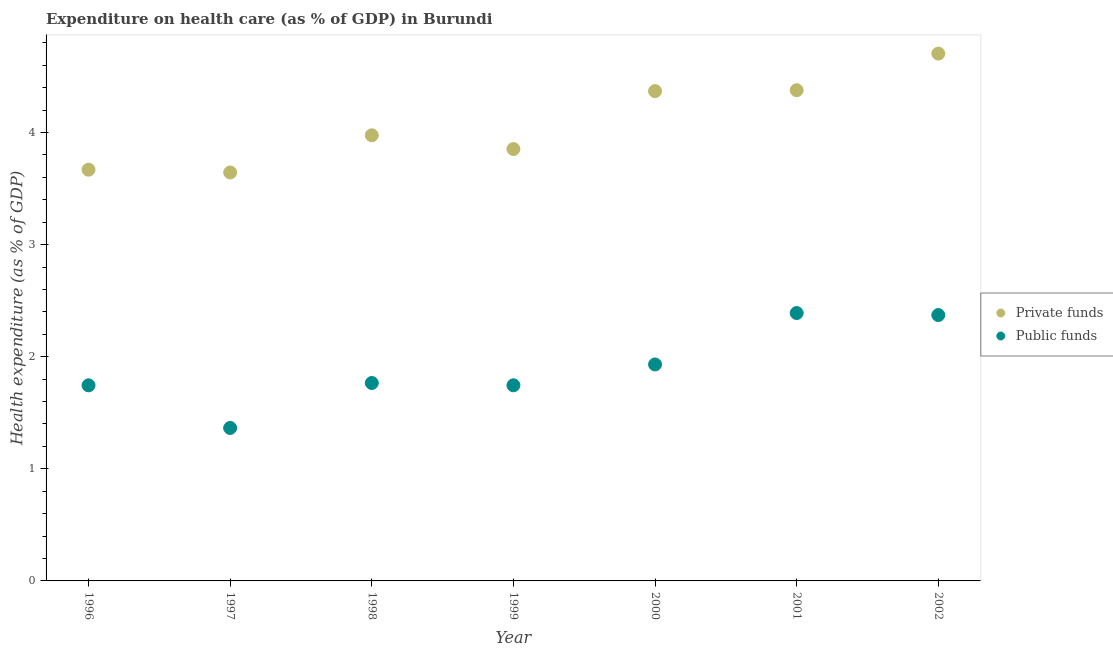What is the amount of private funds spent in healthcare in 2002?
Offer a terse response. 4.7. Across all years, what is the maximum amount of public funds spent in healthcare?
Your answer should be compact. 2.39. Across all years, what is the minimum amount of private funds spent in healthcare?
Your answer should be compact. 3.64. In which year was the amount of public funds spent in healthcare maximum?
Provide a short and direct response. 2001. What is the total amount of public funds spent in healthcare in the graph?
Offer a terse response. 13.31. What is the difference between the amount of private funds spent in healthcare in 2000 and that in 2001?
Keep it short and to the point. -0.01. What is the difference between the amount of public funds spent in healthcare in 2001 and the amount of private funds spent in healthcare in 1996?
Provide a short and direct response. -1.28. What is the average amount of public funds spent in healthcare per year?
Offer a terse response. 1.9. In the year 2002, what is the difference between the amount of public funds spent in healthcare and amount of private funds spent in healthcare?
Ensure brevity in your answer.  -2.33. In how many years, is the amount of private funds spent in healthcare greater than 1.4 %?
Provide a succinct answer. 7. What is the ratio of the amount of public funds spent in healthcare in 1996 to that in 1997?
Offer a terse response. 1.28. Is the amount of private funds spent in healthcare in 1999 less than that in 2000?
Your answer should be compact. Yes. What is the difference between the highest and the second highest amount of private funds spent in healthcare?
Keep it short and to the point. 0.33. What is the difference between the highest and the lowest amount of private funds spent in healthcare?
Provide a short and direct response. 1.06. Is the amount of public funds spent in healthcare strictly greater than the amount of private funds spent in healthcare over the years?
Your answer should be compact. No. Is the amount of public funds spent in healthcare strictly less than the amount of private funds spent in healthcare over the years?
Make the answer very short. Yes. How many years are there in the graph?
Offer a very short reply. 7. Where does the legend appear in the graph?
Your answer should be very brief. Center right. How many legend labels are there?
Give a very brief answer. 2. What is the title of the graph?
Offer a very short reply. Expenditure on health care (as % of GDP) in Burundi. Does "Private funds" appear as one of the legend labels in the graph?
Provide a succinct answer. Yes. What is the label or title of the X-axis?
Provide a succinct answer. Year. What is the label or title of the Y-axis?
Your answer should be compact. Health expenditure (as % of GDP). What is the Health expenditure (as % of GDP) in Private funds in 1996?
Your answer should be compact. 3.67. What is the Health expenditure (as % of GDP) of Public funds in 1996?
Keep it short and to the point. 1.74. What is the Health expenditure (as % of GDP) in Private funds in 1997?
Make the answer very short. 3.64. What is the Health expenditure (as % of GDP) in Public funds in 1997?
Keep it short and to the point. 1.36. What is the Health expenditure (as % of GDP) in Private funds in 1998?
Offer a terse response. 3.97. What is the Health expenditure (as % of GDP) in Public funds in 1998?
Offer a very short reply. 1.77. What is the Health expenditure (as % of GDP) of Private funds in 1999?
Provide a short and direct response. 3.85. What is the Health expenditure (as % of GDP) in Public funds in 1999?
Ensure brevity in your answer.  1.75. What is the Health expenditure (as % of GDP) of Private funds in 2000?
Give a very brief answer. 4.37. What is the Health expenditure (as % of GDP) in Public funds in 2000?
Your answer should be compact. 1.93. What is the Health expenditure (as % of GDP) in Private funds in 2001?
Offer a terse response. 4.38. What is the Health expenditure (as % of GDP) in Public funds in 2001?
Offer a terse response. 2.39. What is the Health expenditure (as % of GDP) in Private funds in 2002?
Provide a short and direct response. 4.7. What is the Health expenditure (as % of GDP) in Public funds in 2002?
Give a very brief answer. 2.37. Across all years, what is the maximum Health expenditure (as % of GDP) in Private funds?
Offer a terse response. 4.7. Across all years, what is the maximum Health expenditure (as % of GDP) of Public funds?
Your response must be concise. 2.39. Across all years, what is the minimum Health expenditure (as % of GDP) of Private funds?
Offer a very short reply. 3.64. Across all years, what is the minimum Health expenditure (as % of GDP) of Public funds?
Your answer should be compact. 1.36. What is the total Health expenditure (as % of GDP) in Private funds in the graph?
Offer a very short reply. 28.59. What is the total Health expenditure (as % of GDP) of Public funds in the graph?
Offer a very short reply. 13.31. What is the difference between the Health expenditure (as % of GDP) in Private funds in 1996 and that in 1997?
Ensure brevity in your answer.  0.02. What is the difference between the Health expenditure (as % of GDP) of Public funds in 1996 and that in 1997?
Offer a very short reply. 0.38. What is the difference between the Health expenditure (as % of GDP) in Private funds in 1996 and that in 1998?
Your answer should be very brief. -0.31. What is the difference between the Health expenditure (as % of GDP) of Public funds in 1996 and that in 1998?
Ensure brevity in your answer.  -0.02. What is the difference between the Health expenditure (as % of GDP) in Private funds in 1996 and that in 1999?
Give a very brief answer. -0.18. What is the difference between the Health expenditure (as % of GDP) of Public funds in 1996 and that in 1999?
Your answer should be compact. -0. What is the difference between the Health expenditure (as % of GDP) of Private funds in 1996 and that in 2000?
Make the answer very short. -0.7. What is the difference between the Health expenditure (as % of GDP) of Public funds in 1996 and that in 2000?
Give a very brief answer. -0.19. What is the difference between the Health expenditure (as % of GDP) in Private funds in 1996 and that in 2001?
Make the answer very short. -0.71. What is the difference between the Health expenditure (as % of GDP) in Public funds in 1996 and that in 2001?
Make the answer very short. -0.64. What is the difference between the Health expenditure (as % of GDP) in Private funds in 1996 and that in 2002?
Your answer should be very brief. -1.04. What is the difference between the Health expenditure (as % of GDP) of Public funds in 1996 and that in 2002?
Make the answer very short. -0.63. What is the difference between the Health expenditure (as % of GDP) of Private funds in 1997 and that in 1998?
Provide a succinct answer. -0.33. What is the difference between the Health expenditure (as % of GDP) of Public funds in 1997 and that in 1998?
Give a very brief answer. -0.4. What is the difference between the Health expenditure (as % of GDP) of Private funds in 1997 and that in 1999?
Your answer should be very brief. -0.21. What is the difference between the Health expenditure (as % of GDP) in Public funds in 1997 and that in 1999?
Ensure brevity in your answer.  -0.38. What is the difference between the Health expenditure (as % of GDP) in Private funds in 1997 and that in 2000?
Offer a terse response. -0.73. What is the difference between the Health expenditure (as % of GDP) in Public funds in 1997 and that in 2000?
Your answer should be compact. -0.57. What is the difference between the Health expenditure (as % of GDP) of Private funds in 1997 and that in 2001?
Your response must be concise. -0.73. What is the difference between the Health expenditure (as % of GDP) in Public funds in 1997 and that in 2001?
Your answer should be compact. -1.02. What is the difference between the Health expenditure (as % of GDP) of Private funds in 1997 and that in 2002?
Make the answer very short. -1.06. What is the difference between the Health expenditure (as % of GDP) of Public funds in 1997 and that in 2002?
Ensure brevity in your answer.  -1.01. What is the difference between the Health expenditure (as % of GDP) in Private funds in 1998 and that in 1999?
Provide a succinct answer. 0.12. What is the difference between the Health expenditure (as % of GDP) of Public funds in 1998 and that in 1999?
Offer a terse response. 0.02. What is the difference between the Health expenditure (as % of GDP) in Private funds in 1998 and that in 2000?
Provide a succinct answer. -0.39. What is the difference between the Health expenditure (as % of GDP) of Public funds in 1998 and that in 2000?
Keep it short and to the point. -0.17. What is the difference between the Health expenditure (as % of GDP) of Private funds in 1998 and that in 2001?
Your response must be concise. -0.4. What is the difference between the Health expenditure (as % of GDP) of Public funds in 1998 and that in 2001?
Your answer should be compact. -0.62. What is the difference between the Health expenditure (as % of GDP) in Private funds in 1998 and that in 2002?
Provide a short and direct response. -0.73. What is the difference between the Health expenditure (as % of GDP) of Public funds in 1998 and that in 2002?
Your response must be concise. -0.61. What is the difference between the Health expenditure (as % of GDP) in Private funds in 1999 and that in 2000?
Your answer should be compact. -0.52. What is the difference between the Health expenditure (as % of GDP) of Public funds in 1999 and that in 2000?
Offer a very short reply. -0.19. What is the difference between the Health expenditure (as % of GDP) of Private funds in 1999 and that in 2001?
Ensure brevity in your answer.  -0.52. What is the difference between the Health expenditure (as % of GDP) in Public funds in 1999 and that in 2001?
Provide a succinct answer. -0.64. What is the difference between the Health expenditure (as % of GDP) in Private funds in 1999 and that in 2002?
Keep it short and to the point. -0.85. What is the difference between the Health expenditure (as % of GDP) of Public funds in 1999 and that in 2002?
Provide a succinct answer. -0.63. What is the difference between the Health expenditure (as % of GDP) of Private funds in 2000 and that in 2001?
Your answer should be very brief. -0.01. What is the difference between the Health expenditure (as % of GDP) in Public funds in 2000 and that in 2001?
Ensure brevity in your answer.  -0.46. What is the difference between the Health expenditure (as % of GDP) of Private funds in 2000 and that in 2002?
Make the answer very short. -0.33. What is the difference between the Health expenditure (as % of GDP) in Public funds in 2000 and that in 2002?
Ensure brevity in your answer.  -0.44. What is the difference between the Health expenditure (as % of GDP) in Private funds in 2001 and that in 2002?
Your answer should be very brief. -0.33. What is the difference between the Health expenditure (as % of GDP) in Public funds in 2001 and that in 2002?
Provide a succinct answer. 0.02. What is the difference between the Health expenditure (as % of GDP) of Private funds in 1996 and the Health expenditure (as % of GDP) of Public funds in 1997?
Give a very brief answer. 2.3. What is the difference between the Health expenditure (as % of GDP) of Private funds in 1996 and the Health expenditure (as % of GDP) of Public funds in 1998?
Your answer should be very brief. 1.9. What is the difference between the Health expenditure (as % of GDP) of Private funds in 1996 and the Health expenditure (as % of GDP) of Public funds in 1999?
Provide a short and direct response. 1.92. What is the difference between the Health expenditure (as % of GDP) of Private funds in 1996 and the Health expenditure (as % of GDP) of Public funds in 2000?
Provide a succinct answer. 1.74. What is the difference between the Health expenditure (as % of GDP) of Private funds in 1996 and the Health expenditure (as % of GDP) of Public funds in 2001?
Offer a terse response. 1.28. What is the difference between the Health expenditure (as % of GDP) in Private funds in 1996 and the Health expenditure (as % of GDP) in Public funds in 2002?
Ensure brevity in your answer.  1.3. What is the difference between the Health expenditure (as % of GDP) of Private funds in 1997 and the Health expenditure (as % of GDP) of Public funds in 1998?
Your response must be concise. 1.88. What is the difference between the Health expenditure (as % of GDP) in Private funds in 1997 and the Health expenditure (as % of GDP) in Public funds in 1999?
Keep it short and to the point. 1.9. What is the difference between the Health expenditure (as % of GDP) in Private funds in 1997 and the Health expenditure (as % of GDP) in Public funds in 2000?
Your answer should be very brief. 1.71. What is the difference between the Health expenditure (as % of GDP) of Private funds in 1997 and the Health expenditure (as % of GDP) of Public funds in 2001?
Provide a short and direct response. 1.25. What is the difference between the Health expenditure (as % of GDP) of Private funds in 1997 and the Health expenditure (as % of GDP) of Public funds in 2002?
Offer a very short reply. 1.27. What is the difference between the Health expenditure (as % of GDP) of Private funds in 1998 and the Health expenditure (as % of GDP) of Public funds in 1999?
Your response must be concise. 2.23. What is the difference between the Health expenditure (as % of GDP) in Private funds in 1998 and the Health expenditure (as % of GDP) in Public funds in 2000?
Provide a short and direct response. 2.04. What is the difference between the Health expenditure (as % of GDP) of Private funds in 1998 and the Health expenditure (as % of GDP) of Public funds in 2001?
Offer a very short reply. 1.59. What is the difference between the Health expenditure (as % of GDP) in Private funds in 1998 and the Health expenditure (as % of GDP) in Public funds in 2002?
Give a very brief answer. 1.6. What is the difference between the Health expenditure (as % of GDP) in Private funds in 1999 and the Health expenditure (as % of GDP) in Public funds in 2000?
Give a very brief answer. 1.92. What is the difference between the Health expenditure (as % of GDP) in Private funds in 1999 and the Health expenditure (as % of GDP) in Public funds in 2001?
Your answer should be very brief. 1.46. What is the difference between the Health expenditure (as % of GDP) of Private funds in 1999 and the Health expenditure (as % of GDP) of Public funds in 2002?
Offer a terse response. 1.48. What is the difference between the Health expenditure (as % of GDP) of Private funds in 2000 and the Health expenditure (as % of GDP) of Public funds in 2001?
Keep it short and to the point. 1.98. What is the difference between the Health expenditure (as % of GDP) of Private funds in 2000 and the Health expenditure (as % of GDP) of Public funds in 2002?
Provide a short and direct response. 2. What is the difference between the Health expenditure (as % of GDP) in Private funds in 2001 and the Health expenditure (as % of GDP) in Public funds in 2002?
Ensure brevity in your answer.  2.01. What is the average Health expenditure (as % of GDP) in Private funds per year?
Ensure brevity in your answer.  4.08. What is the average Health expenditure (as % of GDP) of Public funds per year?
Keep it short and to the point. 1.9. In the year 1996, what is the difference between the Health expenditure (as % of GDP) of Private funds and Health expenditure (as % of GDP) of Public funds?
Offer a terse response. 1.92. In the year 1997, what is the difference between the Health expenditure (as % of GDP) of Private funds and Health expenditure (as % of GDP) of Public funds?
Your answer should be compact. 2.28. In the year 1998, what is the difference between the Health expenditure (as % of GDP) of Private funds and Health expenditure (as % of GDP) of Public funds?
Offer a terse response. 2.21. In the year 1999, what is the difference between the Health expenditure (as % of GDP) of Private funds and Health expenditure (as % of GDP) of Public funds?
Give a very brief answer. 2.11. In the year 2000, what is the difference between the Health expenditure (as % of GDP) of Private funds and Health expenditure (as % of GDP) of Public funds?
Offer a terse response. 2.44. In the year 2001, what is the difference between the Health expenditure (as % of GDP) of Private funds and Health expenditure (as % of GDP) of Public funds?
Your response must be concise. 1.99. In the year 2002, what is the difference between the Health expenditure (as % of GDP) of Private funds and Health expenditure (as % of GDP) of Public funds?
Give a very brief answer. 2.33. What is the ratio of the Health expenditure (as % of GDP) of Private funds in 1996 to that in 1997?
Ensure brevity in your answer.  1.01. What is the ratio of the Health expenditure (as % of GDP) in Public funds in 1996 to that in 1997?
Offer a terse response. 1.28. What is the ratio of the Health expenditure (as % of GDP) in Private funds in 1996 to that in 1998?
Your response must be concise. 0.92. What is the ratio of the Health expenditure (as % of GDP) in Public funds in 1996 to that in 1998?
Offer a very short reply. 0.99. What is the ratio of the Health expenditure (as % of GDP) of Private funds in 1996 to that in 1999?
Your response must be concise. 0.95. What is the ratio of the Health expenditure (as % of GDP) of Private funds in 1996 to that in 2000?
Offer a terse response. 0.84. What is the ratio of the Health expenditure (as % of GDP) in Public funds in 1996 to that in 2000?
Ensure brevity in your answer.  0.9. What is the ratio of the Health expenditure (as % of GDP) in Private funds in 1996 to that in 2001?
Provide a succinct answer. 0.84. What is the ratio of the Health expenditure (as % of GDP) of Public funds in 1996 to that in 2001?
Ensure brevity in your answer.  0.73. What is the ratio of the Health expenditure (as % of GDP) in Private funds in 1996 to that in 2002?
Keep it short and to the point. 0.78. What is the ratio of the Health expenditure (as % of GDP) in Public funds in 1996 to that in 2002?
Your answer should be very brief. 0.74. What is the ratio of the Health expenditure (as % of GDP) in Private funds in 1997 to that in 1998?
Give a very brief answer. 0.92. What is the ratio of the Health expenditure (as % of GDP) of Public funds in 1997 to that in 1998?
Ensure brevity in your answer.  0.77. What is the ratio of the Health expenditure (as % of GDP) of Private funds in 1997 to that in 1999?
Ensure brevity in your answer.  0.95. What is the ratio of the Health expenditure (as % of GDP) in Public funds in 1997 to that in 1999?
Keep it short and to the point. 0.78. What is the ratio of the Health expenditure (as % of GDP) of Private funds in 1997 to that in 2000?
Offer a very short reply. 0.83. What is the ratio of the Health expenditure (as % of GDP) in Public funds in 1997 to that in 2000?
Offer a very short reply. 0.71. What is the ratio of the Health expenditure (as % of GDP) of Private funds in 1997 to that in 2001?
Give a very brief answer. 0.83. What is the ratio of the Health expenditure (as % of GDP) in Public funds in 1997 to that in 2001?
Give a very brief answer. 0.57. What is the ratio of the Health expenditure (as % of GDP) of Private funds in 1997 to that in 2002?
Provide a short and direct response. 0.77. What is the ratio of the Health expenditure (as % of GDP) of Public funds in 1997 to that in 2002?
Offer a very short reply. 0.58. What is the ratio of the Health expenditure (as % of GDP) of Private funds in 1998 to that in 1999?
Keep it short and to the point. 1.03. What is the ratio of the Health expenditure (as % of GDP) in Public funds in 1998 to that in 1999?
Your answer should be very brief. 1.01. What is the ratio of the Health expenditure (as % of GDP) in Private funds in 1998 to that in 2000?
Ensure brevity in your answer.  0.91. What is the ratio of the Health expenditure (as % of GDP) in Public funds in 1998 to that in 2000?
Provide a short and direct response. 0.91. What is the ratio of the Health expenditure (as % of GDP) of Private funds in 1998 to that in 2001?
Your answer should be very brief. 0.91. What is the ratio of the Health expenditure (as % of GDP) of Public funds in 1998 to that in 2001?
Offer a terse response. 0.74. What is the ratio of the Health expenditure (as % of GDP) in Private funds in 1998 to that in 2002?
Make the answer very short. 0.84. What is the ratio of the Health expenditure (as % of GDP) of Public funds in 1998 to that in 2002?
Your answer should be compact. 0.74. What is the ratio of the Health expenditure (as % of GDP) in Private funds in 1999 to that in 2000?
Keep it short and to the point. 0.88. What is the ratio of the Health expenditure (as % of GDP) in Public funds in 1999 to that in 2000?
Make the answer very short. 0.9. What is the ratio of the Health expenditure (as % of GDP) in Private funds in 1999 to that in 2001?
Offer a terse response. 0.88. What is the ratio of the Health expenditure (as % of GDP) of Public funds in 1999 to that in 2001?
Make the answer very short. 0.73. What is the ratio of the Health expenditure (as % of GDP) in Private funds in 1999 to that in 2002?
Offer a terse response. 0.82. What is the ratio of the Health expenditure (as % of GDP) in Public funds in 1999 to that in 2002?
Ensure brevity in your answer.  0.74. What is the ratio of the Health expenditure (as % of GDP) of Private funds in 2000 to that in 2001?
Offer a terse response. 1. What is the ratio of the Health expenditure (as % of GDP) in Public funds in 2000 to that in 2001?
Your response must be concise. 0.81. What is the ratio of the Health expenditure (as % of GDP) in Private funds in 2000 to that in 2002?
Offer a very short reply. 0.93. What is the ratio of the Health expenditure (as % of GDP) in Public funds in 2000 to that in 2002?
Your response must be concise. 0.81. What is the ratio of the Health expenditure (as % of GDP) of Private funds in 2001 to that in 2002?
Keep it short and to the point. 0.93. What is the ratio of the Health expenditure (as % of GDP) of Public funds in 2001 to that in 2002?
Offer a terse response. 1.01. What is the difference between the highest and the second highest Health expenditure (as % of GDP) of Private funds?
Give a very brief answer. 0.33. What is the difference between the highest and the second highest Health expenditure (as % of GDP) in Public funds?
Give a very brief answer. 0.02. What is the difference between the highest and the lowest Health expenditure (as % of GDP) in Private funds?
Offer a very short reply. 1.06. What is the difference between the highest and the lowest Health expenditure (as % of GDP) in Public funds?
Keep it short and to the point. 1.02. 